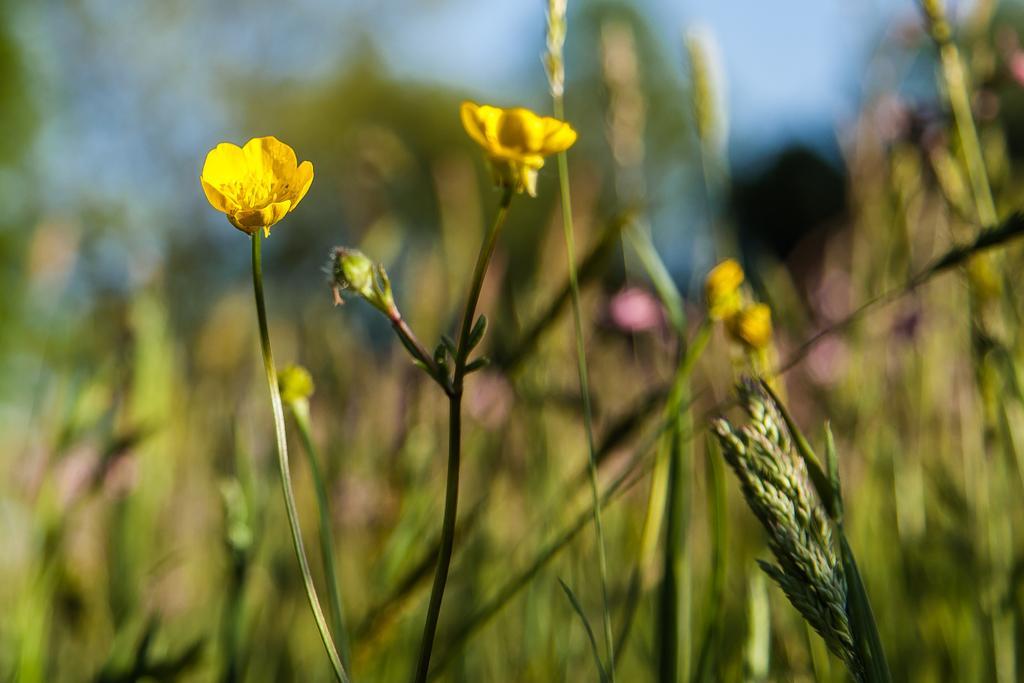Describe this image in one or two sentences. There are flower plants and buds in the foreground area of the image and the background is blurry. 